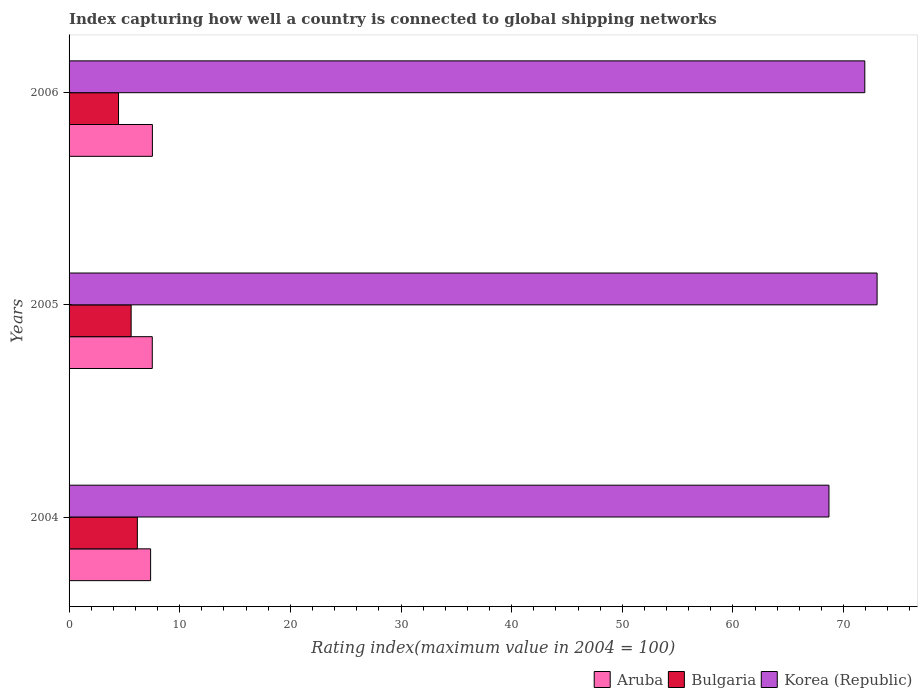Are the number of bars on each tick of the Y-axis equal?
Keep it short and to the point. Yes. How many bars are there on the 2nd tick from the top?
Your response must be concise. 3. What is the label of the 1st group of bars from the top?
Provide a succinct answer. 2006. In how many cases, is the number of bars for a given year not equal to the number of legend labels?
Your answer should be very brief. 0. What is the rating index in Bulgaria in 2004?
Your answer should be compact. 6.17. Across all years, what is the maximum rating index in Bulgaria?
Provide a short and direct response. 6.17. Across all years, what is the minimum rating index in Korea (Republic)?
Your answer should be very brief. 68.68. In which year was the rating index in Korea (Republic) maximum?
Provide a succinct answer. 2005. What is the total rating index in Aruba in the graph?
Your answer should be very brief. 22.42. What is the difference between the rating index in Korea (Republic) in 2004 and that in 2005?
Your answer should be compact. -4.35. What is the difference between the rating index in Aruba in 2004 and the rating index in Korea (Republic) in 2005?
Your answer should be very brief. -65.66. What is the average rating index in Korea (Republic) per year?
Your response must be concise. 71.21. In the year 2005, what is the difference between the rating index in Aruba and rating index in Korea (Republic)?
Give a very brief answer. -65.51. What is the ratio of the rating index in Aruba in 2004 to that in 2006?
Your answer should be compact. 0.98. Is the difference between the rating index in Aruba in 2005 and 2006 greater than the difference between the rating index in Korea (Republic) in 2005 and 2006?
Provide a short and direct response. No. What is the difference between the highest and the second highest rating index in Bulgaria?
Keep it short and to the point. 0.56. What is the difference between the highest and the lowest rating index in Korea (Republic)?
Your answer should be compact. 4.35. In how many years, is the rating index in Bulgaria greater than the average rating index in Bulgaria taken over all years?
Your answer should be compact. 2. Is the sum of the rating index in Bulgaria in 2004 and 2005 greater than the maximum rating index in Aruba across all years?
Provide a short and direct response. Yes. What does the 1st bar from the top in 2005 represents?
Make the answer very short. Korea (Republic). Is it the case that in every year, the sum of the rating index in Bulgaria and rating index in Korea (Republic) is greater than the rating index in Aruba?
Keep it short and to the point. Yes. How many years are there in the graph?
Provide a short and direct response. 3. What is the difference between two consecutive major ticks on the X-axis?
Your answer should be very brief. 10. Are the values on the major ticks of X-axis written in scientific E-notation?
Make the answer very short. No. Does the graph contain any zero values?
Provide a short and direct response. No. Does the graph contain grids?
Your answer should be compact. No. How many legend labels are there?
Keep it short and to the point. 3. How are the legend labels stacked?
Provide a short and direct response. Horizontal. What is the title of the graph?
Offer a very short reply. Index capturing how well a country is connected to global shipping networks. What is the label or title of the X-axis?
Your response must be concise. Rating index(maximum value in 2004 = 100). What is the label or title of the Y-axis?
Your response must be concise. Years. What is the Rating index(maximum value in 2004 = 100) of Aruba in 2004?
Ensure brevity in your answer.  7.37. What is the Rating index(maximum value in 2004 = 100) in Bulgaria in 2004?
Ensure brevity in your answer.  6.17. What is the Rating index(maximum value in 2004 = 100) of Korea (Republic) in 2004?
Ensure brevity in your answer.  68.68. What is the Rating index(maximum value in 2004 = 100) in Aruba in 2005?
Give a very brief answer. 7.52. What is the Rating index(maximum value in 2004 = 100) in Bulgaria in 2005?
Provide a short and direct response. 5.61. What is the Rating index(maximum value in 2004 = 100) in Korea (Republic) in 2005?
Your response must be concise. 73.03. What is the Rating index(maximum value in 2004 = 100) in Aruba in 2006?
Keep it short and to the point. 7.53. What is the Rating index(maximum value in 2004 = 100) in Bulgaria in 2006?
Keep it short and to the point. 4.47. What is the Rating index(maximum value in 2004 = 100) in Korea (Republic) in 2006?
Offer a terse response. 71.92. Across all years, what is the maximum Rating index(maximum value in 2004 = 100) of Aruba?
Ensure brevity in your answer.  7.53. Across all years, what is the maximum Rating index(maximum value in 2004 = 100) of Bulgaria?
Give a very brief answer. 6.17. Across all years, what is the maximum Rating index(maximum value in 2004 = 100) in Korea (Republic)?
Your answer should be compact. 73.03. Across all years, what is the minimum Rating index(maximum value in 2004 = 100) in Aruba?
Provide a short and direct response. 7.37. Across all years, what is the minimum Rating index(maximum value in 2004 = 100) in Bulgaria?
Give a very brief answer. 4.47. Across all years, what is the minimum Rating index(maximum value in 2004 = 100) of Korea (Republic)?
Give a very brief answer. 68.68. What is the total Rating index(maximum value in 2004 = 100) in Aruba in the graph?
Keep it short and to the point. 22.42. What is the total Rating index(maximum value in 2004 = 100) in Bulgaria in the graph?
Your answer should be compact. 16.25. What is the total Rating index(maximum value in 2004 = 100) of Korea (Republic) in the graph?
Give a very brief answer. 213.63. What is the difference between the Rating index(maximum value in 2004 = 100) in Aruba in 2004 and that in 2005?
Offer a very short reply. -0.15. What is the difference between the Rating index(maximum value in 2004 = 100) in Bulgaria in 2004 and that in 2005?
Ensure brevity in your answer.  0.56. What is the difference between the Rating index(maximum value in 2004 = 100) of Korea (Republic) in 2004 and that in 2005?
Provide a succinct answer. -4.35. What is the difference between the Rating index(maximum value in 2004 = 100) in Aruba in 2004 and that in 2006?
Your answer should be compact. -0.16. What is the difference between the Rating index(maximum value in 2004 = 100) in Korea (Republic) in 2004 and that in 2006?
Make the answer very short. -3.24. What is the difference between the Rating index(maximum value in 2004 = 100) in Aruba in 2005 and that in 2006?
Your answer should be very brief. -0.01. What is the difference between the Rating index(maximum value in 2004 = 100) in Bulgaria in 2005 and that in 2006?
Offer a very short reply. 1.14. What is the difference between the Rating index(maximum value in 2004 = 100) in Korea (Republic) in 2005 and that in 2006?
Your answer should be very brief. 1.11. What is the difference between the Rating index(maximum value in 2004 = 100) of Aruba in 2004 and the Rating index(maximum value in 2004 = 100) of Bulgaria in 2005?
Provide a succinct answer. 1.76. What is the difference between the Rating index(maximum value in 2004 = 100) of Aruba in 2004 and the Rating index(maximum value in 2004 = 100) of Korea (Republic) in 2005?
Your answer should be compact. -65.66. What is the difference between the Rating index(maximum value in 2004 = 100) of Bulgaria in 2004 and the Rating index(maximum value in 2004 = 100) of Korea (Republic) in 2005?
Provide a succinct answer. -66.86. What is the difference between the Rating index(maximum value in 2004 = 100) of Aruba in 2004 and the Rating index(maximum value in 2004 = 100) of Korea (Republic) in 2006?
Give a very brief answer. -64.55. What is the difference between the Rating index(maximum value in 2004 = 100) of Bulgaria in 2004 and the Rating index(maximum value in 2004 = 100) of Korea (Republic) in 2006?
Provide a succinct answer. -65.75. What is the difference between the Rating index(maximum value in 2004 = 100) of Aruba in 2005 and the Rating index(maximum value in 2004 = 100) of Bulgaria in 2006?
Provide a succinct answer. 3.05. What is the difference between the Rating index(maximum value in 2004 = 100) in Aruba in 2005 and the Rating index(maximum value in 2004 = 100) in Korea (Republic) in 2006?
Provide a succinct answer. -64.4. What is the difference between the Rating index(maximum value in 2004 = 100) of Bulgaria in 2005 and the Rating index(maximum value in 2004 = 100) of Korea (Republic) in 2006?
Provide a short and direct response. -66.31. What is the average Rating index(maximum value in 2004 = 100) of Aruba per year?
Your answer should be very brief. 7.47. What is the average Rating index(maximum value in 2004 = 100) of Bulgaria per year?
Make the answer very short. 5.42. What is the average Rating index(maximum value in 2004 = 100) of Korea (Republic) per year?
Provide a succinct answer. 71.21. In the year 2004, what is the difference between the Rating index(maximum value in 2004 = 100) in Aruba and Rating index(maximum value in 2004 = 100) in Bulgaria?
Offer a very short reply. 1.2. In the year 2004, what is the difference between the Rating index(maximum value in 2004 = 100) of Aruba and Rating index(maximum value in 2004 = 100) of Korea (Republic)?
Give a very brief answer. -61.31. In the year 2004, what is the difference between the Rating index(maximum value in 2004 = 100) in Bulgaria and Rating index(maximum value in 2004 = 100) in Korea (Republic)?
Make the answer very short. -62.51. In the year 2005, what is the difference between the Rating index(maximum value in 2004 = 100) of Aruba and Rating index(maximum value in 2004 = 100) of Bulgaria?
Offer a very short reply. 1.91. In the year 2005, what is the difference between the Rating index(maximum value in 2004 = 100) of Aruba and Rating index(maximum value in 2004 = 100) of Korea (Republic)?
Make the answer very short. -65.51. In the year 2005, what is the difference between the Rating index(maximum value in 2004 = 100) of Bulgaria and Rating index(maximum value in 2004 = 100) of Korea (Republic)?
Keep it short and to the point. -67.42. In the year 2006, what is the difference between the Rating index(maximum value in 2004 = 100) of Aruba and Rating index(maximum value in 2004 = 100) of Bulgaria?
Your answer should be very brief. 3.06. In the year 2006, what is the difference between the Rating index(maximum value in 2004 = 100) of Aruba and Rating index(maximum value in 2004 = 100) of Korea (Republic)?
Offer a terse response. -64.39. In the year 2006, what is the difference between the Rating index(maximum value in 2004 = 100) of Bulgaria and Rating index(maximum value in 2004 = 100) of Korea (Republic)?
Offer a terse response. -67.45. What is the ratio of the Rating index(maximum value in 2004 = 100) in Aruba in 2004 to that in 2005?
Give a very brief answer. 0.98. What is the ratio of the Rating index(maximum value in 2004 = 100) of Bulgaria in 2004 to that in 2005?
Provide a short and direct response. 1.1. What is the ratio of the Rating index(maximum value in 2004 = 100) of Korea (Republic) in 2004 to that in 2005?
Provide a short and direct response. 0.94. What is the ratio of the Rating index(maximum value in 2004 = 100) in Aruba in 2004 to that in 2006?
Make the answer very short. 0.98. What is the ratio of the Rating index(maximum value in 2004 = 100) of Bulgaria in 2004 to that in 2006?
Give a very brief answer. 1.38. What is the ratio of the Rating index(maximum value in 2004 = 100) in Korea (Republic) in 2004 to that in 2006?
Offer a very short reply. 0.95. What is the ratio of the Rating index(maximum value in 2004 = 100) in Bulgaria in 2005 to that in 2006?
Offer a very short reply. 1.25. What is the ratio of the Rating index(maximum value in 2004 = 100) of Korea (Republic) in 2005 to that in 2006?
Provide a succinct answer. 1.02. What is the difference between the highest and the second highest Rating index(maximum value in 2004 = 100) in Bulgaria?
Keep it short and to the point. 0.56. What is the difference between the highest and the second highest Rating index(maximum value in 2004 = 100) in Korea (Republic)?
Keep it short and to the point. 1.11. What is the difference between the highest and the lowest Rating index(maximum value in 2004 = 100) in Aruba?
Your response must be concise. 0.16. What is the difference between the highest and the lowest Rating index(maximum value in 2004 = 100) in Korea (Republic)?
Keep it short and to the point. 4.35. 